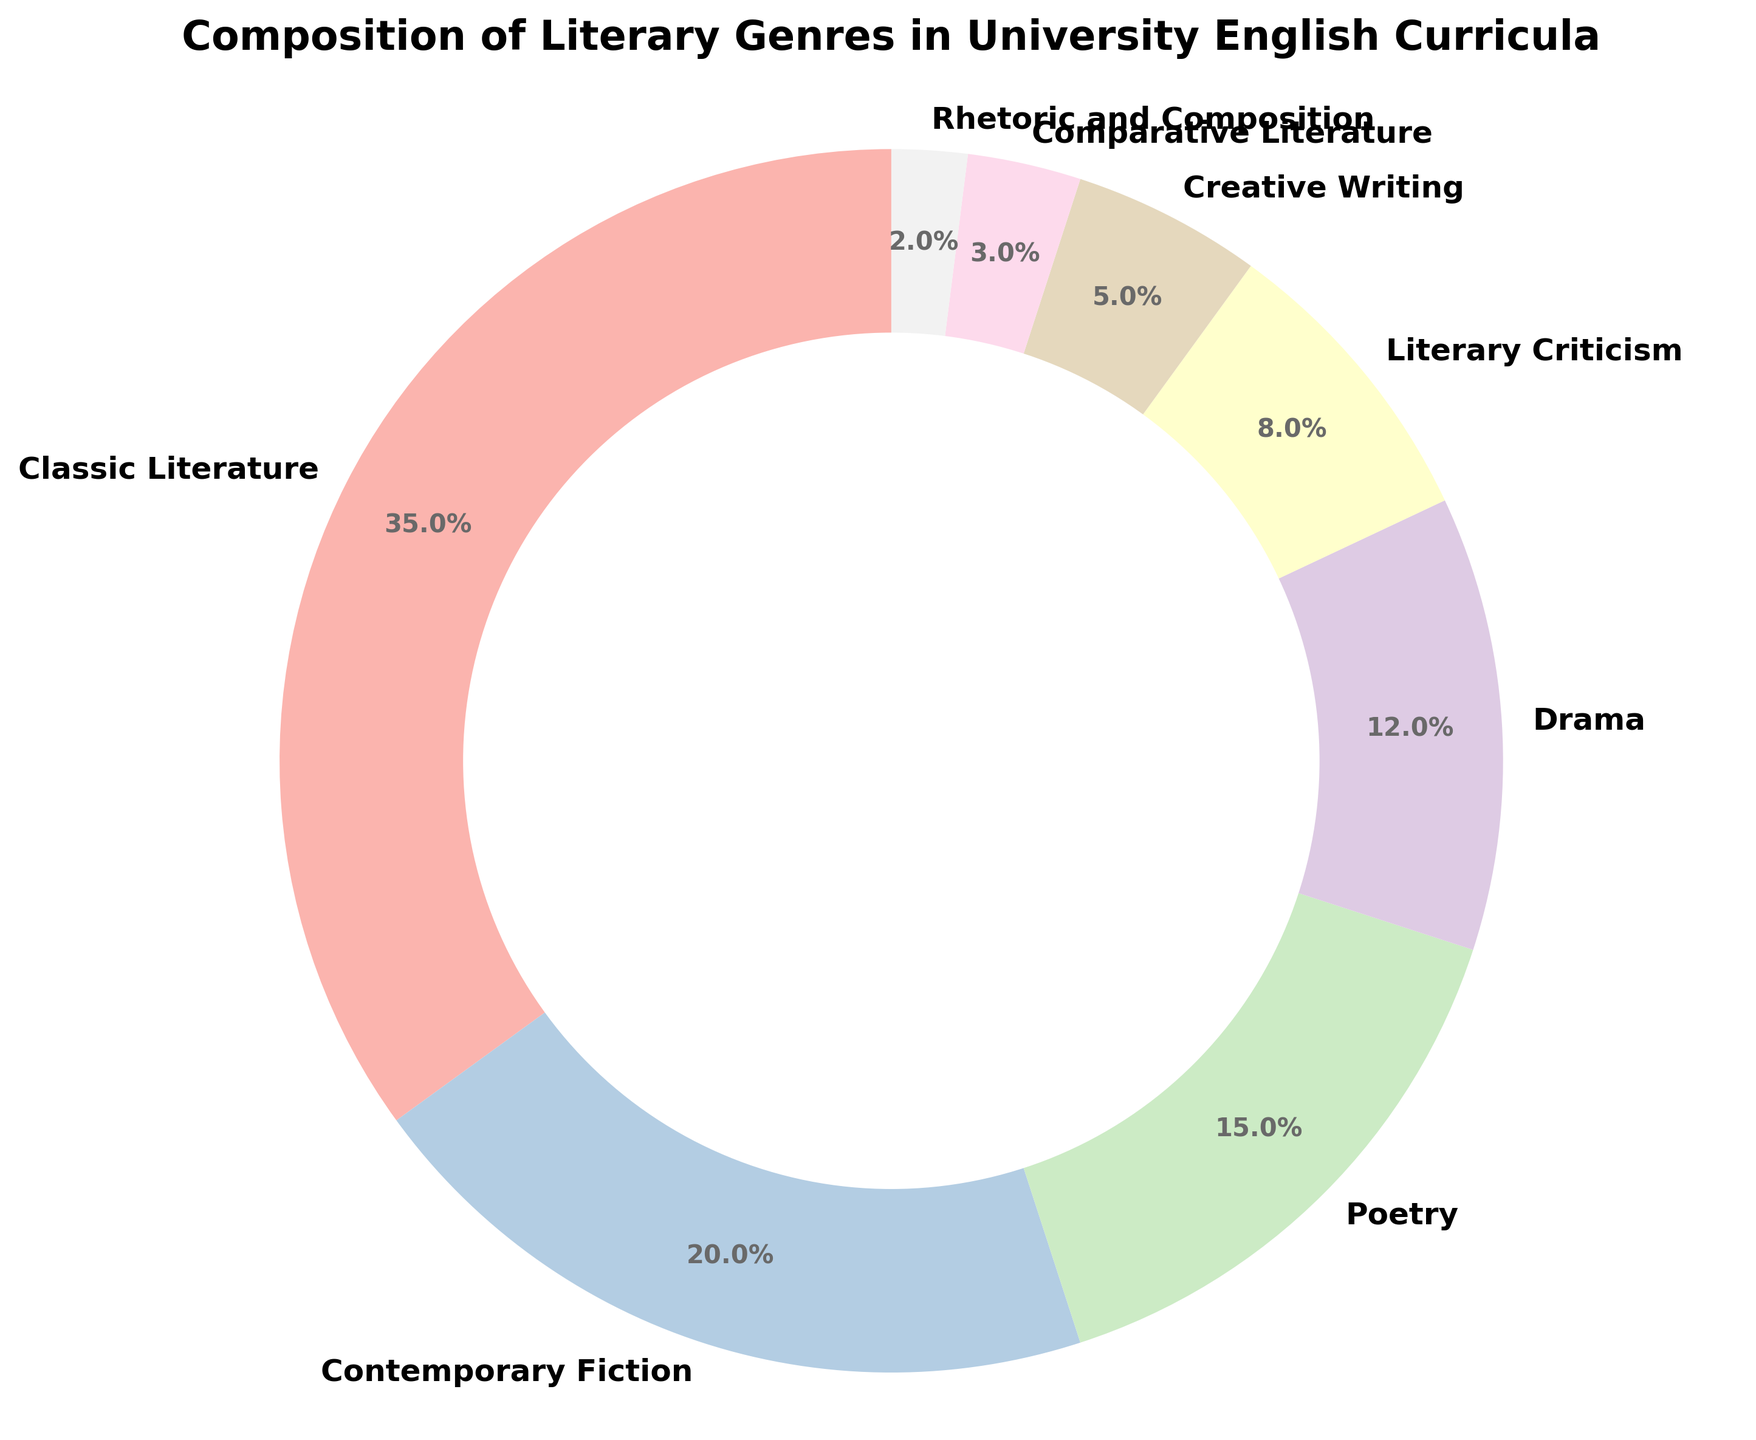What's the sum of the percentages of Classic Literature and Contemporary Fiction? Sum the percentages of "Classic Literature" and "Contemporary Fiction": 35 + 20 = 55.
Answer: 55% Which genre has the smallest percentage in the curriculum? Identify the genre with the lowest percentage from the pie chart; "Rhetoric and Composition" is 2%, which is the smallest.
Answer: Rhetoric and Composition Is the percentage of Drama greater than that of Creative Writing? Compare the percentages of "Drama" and "Creative Writing": Drama is 12%, and Creative Writing is 5%.
Answer: Yes What is the difference in percentage points between Classic Literature and Poetry? Subtract the percentage of "Poetry" from "Classic Literature": 35 - 15 = 20.
Answer: 20% How many genres have a percentage higher than 10%? Count the genres with percentages greater than 10%: "Classic Literature", "Contemporary Fiction", "Poetry", "Drama".
Answer: 4 What percentage of the curriculum consists of Literary Criticism and Creative Writing combined? Sum the percentages of "Literary Criticism" and "Creative Writing": 8 + 5 = 13.
Answer: 13% Which genre represents the largest portion of the curriculum? Identify the genre with the highest percentage in the pie chart; "Classic Literature" has 35%, which is the largest.
Answer: Classic Literature Compare the percentages of Comparative Literature and Rhetoric and Composition. Which is higher? Compare the percentages of "Comparative Literature" (3%) and "Rhetoric and Composition" (2%) to determine which is higher.
Answer: Comparative Literature Is the percentage of Poetry equal to the combined percentage of Creative Writing and Comparative Literature? Compare the percentage of "Poetry" (15%) with the sum of "Creative Writing" and "Comparative Literature" (5 + 3 = 8).
Answer: No 